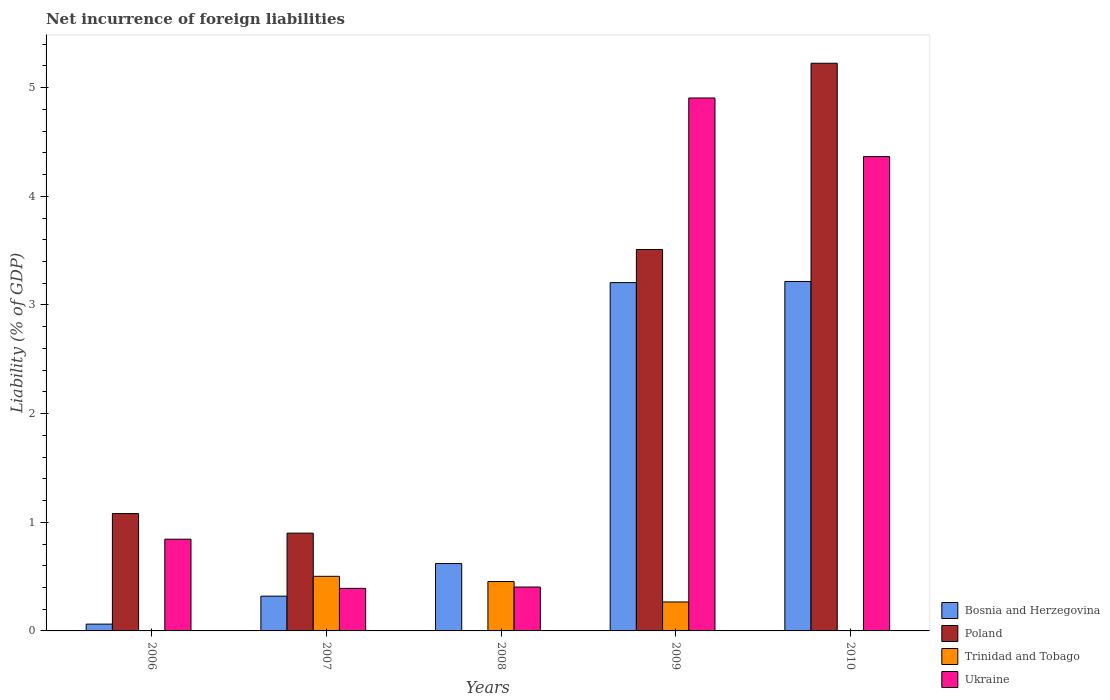How many different coloured bars are there?
Your response must be concise. 4. How many groups of bars are there?
Keep it short and to the point. 5. How many bars are there on the 1st tick from the left?
Offer a terse response. 3. What is the label of the 3rd group of bars from the left?
Provide a short and direct response. 2008. In how many cases, is the number of bars for a given year not equal to the number of legend labels?
Make the answer very short. 3. What is the net incurrence of foreign liabilities in Ukraine in 2009?
Your answer should be compact. 4.91. Across all years, what is the maximum net incurrence of foreign liabilities in Trinidad and Tobago?
Give a very brief answer. 0.5. In which year was the net incurrence of foreign liabilities in Trinidad and Tobago maximum?
Provide a succinct answer. 2007. What is the total net incurrence of foreign liabilities in Trinidad and Tobago in the graph?
Offer a terse response. 1.22. What is the difference between the net incurrence of foreign liabilities in Bosnia and Herzegovina in 2007 and that in 2009?
Your response must be concise. -2.89. What is the difference between the net incurrence of foreign liabilities in Poland in 2008 and the net incurrence of foreign liabilities in Trinidad and Tobago in 2007?
Your answer should be very brief. -0.5. What is the average net incurrence of foreign liabilities in Trinidad and Tobago per year?
Offer a terse response. 0.24. In the year 2010, what is the difference between the net incurrence of foreign liabilities in Bosnia and Herzegovina and net incurrence of foreign liabilities in Poland?
Offer a terse response. -2.01. What is the ratio of the net incurrence of foreign liabilities in Ukraine in 2007 to that in 2008?
Your answer should be very brief. 0.97. Is the difference between the net incurrence of foreign liabilities in Bosnia and Herzegovina in 2006 and 2010 greater than the difference between the net incurrence of foreign liabilities in Poland in 2006 and 2010?
Your answer should be very brief. Yes. What is the difference between the highest and the second highest net incurrence of foreign liabilities in Ukraine?
Keep it short and to the point. 0.54. What is the difference between the highest and the lowest net incurrence of foreign liabilities in Bosnia and Herzegovina?
Your answer should be compact. 3.15. In how many years, is the net incurrence of foreign liabilities in Trinidad and Tobago greater than the average net incurrence of foreign liabilities in Trinidad and Tobago taken over all years?
Provide a succinct answer. 3. Is it the case that in every year, the sum of the net incurrence of foreign liabilities in Poland and net incurrence of foreign liabilities in Ukraine is greater than the sum of net incurrence of foreign liabilities in Trinidad and Tobago and net incurrence of foreign liabilities in Bosnia and Herzegovina?
Provide a short and direct response. No. Is it the case that in every year, the sum of the net incurrence of foreign liabilities in Bosnia and Herzegovina and net incurrence of foreign liabilities in Poland is greater than the net incurrence of foreign liabilities in Ukraine?
Offer a terse response. Yes. Are all the bars in the graph horizontal?
Your answer should be very brief. No. What is the difference between two consecutive major ticks on the Y-axis?
Your answer should be compact. 1. Does the graph contain any zero values?
Provide a succinct answer. Yes. Where does the legend appear in the graph?
Your answer should be compact. Bottom right. What is the title of the graph?
Your answer should be very brief. Net incurrence of foreign liabilities. Does "Somalia" appear as one of the legend labels in the graph?
Your answer should be very brief. No. What is the label or title of the Y-axis?
Make the answer very short. Liability (% of GDP). What is the Liability (% of GDP) in Bosnia and Herzegovina in 2006?
Your answer should be very brief. 0.06. What is the Liability (% of GDP) in Poland in 2006?
Keep it short and to the point. 1.08. What is the Liability (% of GDP) of Trinidad and Tobago in 2006?
Make the answer very short. 0. What is the Liability (% of GDP) in Ukraine in 2006?
Offer a terse response. 0.84. What is the Liability (% of GDP) of Bosnia and Herzegovina in 2007?
Your answer should be very brief. 0.32. What is the Liability (% of GDP) in Poland in 2007?
Your answer should be very brief. 0.9. What is the Liability (% of GDP) in Trinidad and Tobago in 2007?
Ensure brevity in your answer.  0.5. What is the Liability (% of GDP) of Ukraine in 2007?
Ensure brevity in your answer.  0.39. What is the Liability (% of GDP) of Bosnia and Herzegovina in 2008?
Provide a succinct answer. 0.62. What is the Liability (% of GDP) of Poland in 2008?
Provide a short and direct response. 0. What is the Liability (% of GDP) of Trinidad and Tobago in 2008?
Provide a succinct answer. 0.45. What is the Liability (% of GDP) in Ukraine in 2008?
Provide a succinct answer. 0.4. What is the Liability (% of GDP) in Bosnia and Herzegovina in 2009?
Keep it short and to the point. 3.21. What is the Liability (% of GDP) of Poland in 2009?
Give a very brief answer. 3.51. What is the Liability (% of GDP) in Trinidad and Tobago in 2009?
Offer a very short reply. 0.27. What is the Liability (% of GDP) of Ukraine in 2009?
Offer a terse response. 4.91. What is the Liability (% of GDP) in Bosnia and Herzegovina in 2010?
Give a very brief answer. 3.22. What is the Liability (% of GDP) in Poland in 2010?
Ensure brevity in your answer.  5.22. What is the Liability (% of GDP) of Trinidad and Tobago in 2010?
Provide a short and direct response. 0. What is the Liability (% of GDP) in Ukraine in 2010?
Provide a succinct answer. 4.37. Across all years, what is the maximum Liability (% of GDP) of Bosnia and Herzegovina?
Offer a very short reply. 3.22. Across all years, what is the maximum Liability (% of GDP) in Poland?
Offer a terse response. 5.22. Across all years, what is the maximum Liability (% of GDP) in Trinidad and Tobago?
Ensure brevity in your answer.  0.5. Across all years, what is the maximum Liability (% of GDP) in Ukraine?
Your response must be concise. 4.91. Across all years, what is the minimum Liability (% of GDP) in Bosnia and Herzegovina?
Provide a succinct answer. 0.06. Across all years, what is the minimum Liability (% of GDP) in Poland?
Offer a terse response. 0. Across all years, what is the minimum Liability (% of GDP) in Ukraine?
Give a very brief answer. 0.39. What is the total Liability (% of GDP) in Bosnia and Herzegovina in the graph?
Your answer should be very brief. 7.42. What is the total Liability (% of GDP) of Poland in the graph?
Provide a succinct answer. 10.72. What is the total Liability (% of GDP) in Trinidad and Tobago in the graph?
Keep it short and to the point. 1.22. What is the total Liability (% of GDP) of Ukraine in the graph?
Your answer should be compact. 10.91. What is the difference between the Liability (% of GDP) in Bosnia and Herzegovina in 2006 and that in 2007?
Give a very brief answer. -0.26. What is the difference between the Liability (% of GDP) in Poland in 2006 and that in 2007?
Keep it short and to the point. 0.18. What is the difference between the Liability (% of GDP) of Ukraine in 2006 and that in 2007?
Your answer should be very brief. 0.45. What is the difference between the Liability (% of GDP) in Bosnia and Herzegovina in 2006 and that in 2008?
Offer a very short reply. -0.56. What is the difference between the Liability (% of GDP) in Ukraine in 2006 and that in 2008?
Provide a short and direct response. 0.44. What is the difference between the Liability (% of GDP) of Bosnia and Herzegovina in 2006 and that in 2009?
Keep it short and to the point. -3.14. What is the difference between the Liability (% of GDP) of Poland in 2006 and that in 2009?
Give a very brief answer. -2.43. What is the difference between the Liability (% of GDP) in Ukraine in 2006 and that in 2009?
Offer a terse response. -4.06. What is the difference between the Liability (% of GDP) of Bosnia and Herzegovina in 2006 and that in 2010?
Your answer should be compact. -3.15. What is the difference between the Liability (% of GDP) in Poland in 2006 and that in 2010?
Keep it short and to the point. -4.14. What is the difference between the Liability (% of GDP) of Ukraine in 2006 and that in 2010?
Ensure brevity in your answer.  -3.52. What is the difference between the Liability (% of GDP) of Trinidad and Tobago in 2007 and that in 2008?
Provide a short and direct response. 0.05. What is the difference between the Liability (% of GDP) of Ukraine in 2007 and that in 2008?
Ensure brevity in your answer.  -0.01. What is the difference between the Liability (% of GDP) of Bosnia and Herzegovina in 2007 and that in 2009?
Keep it short and to the point. -2.89. What is the difference between the Liability (% of GDP) of Poland in 2007 and that in 2009?
Offer a very short reply. -2.61. What is the difference between the Liability (% of GDP) in Trinidad and Tobago in 2007 and that in 2009?
Your answer should be compact. 0.24. What is the difference between the Liability (% of GDP) in Ukraine in 2007 and that in 2009?
Make the answer very short. -4.51. What is the difference between the Liability (% of GDP) in Bosnia and Herzegovina in 2007 and that in 2010?
Your answer should be compact. -2.9. What is the difference between the Liability (% of GDP) in Poland in 2007 and that in 2010?
Provide a short and direct response. -4.32. What is the difference between the Liability (% of GDP) in Ukraine in 2007 and that in 2010?
Offer a very short reply. -3.97. What is the difference between the Liability (% of GDP) of Bosnia and Herzegovina in 2008 and that in 2009?
Keep it short and to the point. -2.59. What is the difference between the Liability (% of GDP) of Trinidad and Tobago in 2008 and that in 2009?
Ensure brevity in your answer.  0.19. What is the difference between the Liability (% of GDP) of Ukraine in 2008 and that in 2009?
Give a very brief answer. -4.5. What is the difference between the Liability (% of GDP) of Bosnia and Herzegovina in 2008 and that in 2010?
Your response must be concise. -2.6. What is the difference between the Liability (% of GDP) of Ukraine in 2008 and that in 2010?
Give a very brief answer. -3.96. What is the difference between the Liability (% of GDP) in Bosnia and Herzegovina in 2009 and that in 2010?
Your answer should be very brief. -0.01. What is the difference between the Liability (% of GDP) in Poland in 2009 and that in 2010?
Your response must be concise. -1.71. What is the difference between the Liability (% of GDP) of Ukraine in 2009 and that in 2010?
Your answer should be compact. 0.54. What is the difference between the Liability (% of GDP) in Bosnia and Herzegovina in 2006 and the Liability (% of GDP) in Poland in 2007?
Offer a terse response. -0.84. What is the difference between the Liability (% of GDP) of Bosnia and Herzegovina in 2006 and the Liability (% of GDP) of Trinidad and Tobago in 2007?
Your answer should be compact. -0.44. What is the difference between the Liability (% of GDP) of Bosnia and Herzegovina in 2006 and the Liability (% of GDP) of Ukraine in 2007?
Offer a terse response. -0.33. What is the difference between the Liability (% of GDP) in Poland in 2006 and the Liability (% of GDP) in Trinidad and Tobago in 2007?
Make the answer very short. 0.58. What is the difference between the Liability (% of GDP) in Poland in 2006 and the Liability (% of GDP) in Ukraine in 2007?
Offer a very short reply. 0.69. What is the difference between the Liability (% of GDP) of Bosnia and Herzegovina in 2006 and the Liability (% of GDP) of Trinidad and Tobago in 2008?
Provide a succinct answer. -0.39. What is the difference between the Liability (% of GDP) of Bosnia and Herzegovina in 2006 and the Liability (% of GDP) of Ukraine in 2008?
Offer a very short reply. -0.34. What is the difference between the Liability (% of GDP) in Poland in 2006 and the Liability (% of GDP) in Trinidad and Tobago in 2008?
Ensure brevity in your answer.  0.63. What is the difference between the Liability (% of GDP) in Poland in 2006 and the Liability (% of GDP) in Ukraine in 2008?
Give a very brief answer. 0.68. What is the difference between the Liability (% of GDP) in Bosnia and Herzegovina in 2006 and the Liability (% of GDP) in Poland in 2009?
Provide a short and direct response. -3.45. What is the difference between the Liability (% of GDP) of Bosnia and Herzegovina in 2006 and the Liability (% of GDP) of Trinidad and Tobago in 2009?
Provide a short and direct response. -0.2. What is the difference between the Liability (% of GDP) of Bosnia and Herzegovina in 2006 and the Liability (% of GDP) of Ukraine in 2009?
Keep it short and to the point. -4.84. What is the difference between the Liability (% of GDP) in Poland in 2006 and the Liability (% of GDP) in Trinidad and Tobago in 2009?
Make the answer very short. 0.81. What is the difference between the Liability (% of GDP) in Poland in 2006 and the Liability (% of GDP) in Ukraine in 2009?
Ensure brevity in your answer.  -3.83. What is the difference between the Liability (% of GDP) of Bosnia and Herzegovina in 2006 and the Liability (% of GDP) of Poland in 2010?
Give a very brief answer. -5.16. What is the difference between the Liability (% of GDP) in Bosnia and Herzegovina in 2006 and the Liability (% of GDP) in Ukraine in 2010?
Keep it short and to the point. -4.3. What is the difference between the Liability (% of GDP) of Poland in 2006 and the Liability (% of GDP) of Ukraine in 2010?
Ensure brevity in your answer.  -3.29. What is the difference between the Liability (% of GDP) in Bosnia and Herzegovina in 2007 and the Liability (% of GDP) in Trinidad and Tobago in 2008?
Keep it short and to the point. -0.13. What is the difference between the Liability (% of GDP) in Bosnia and Herzegovina in 2007 and the Liability (% of GDP) in Ukraine in 2008?
Keep it short and to the point. -0.08. What is the difference between the Liability (% of GDP) of Poland in 2007 and the Liability (% of GDP) of Trinidad and Tobago in 2008?
Make the answer very short. 0.45. What is the difference between the Liability (% of GDP) of Poland in 2007 and the Liability (% of GDP) of Ukraine in 2008?
Give a very brief answer. 0.5. What is the difference between the Liability (% of GDP) in Trinidad and Tobago in 2007 and the Liability (% of GDP) in Ukraine in 2008?
Your answer should be very brief. 0.1. What is the difference between the Liability (% of GDP) in Bosnia and Herzegovina in 2007 and the Liability (% of GDP) in Poland in 2009?
Provide a succinct answer. -3.19. What is the difference between the Liability (% of GDP) of Bosnia and Herzegovina in 2007 and the Liability (% of GDP) of Trinidad and Tobago in 2009?
Your response must be concise. 0.05. What is the difference between the Liability (% of GDP) of Bosnia and Herzegovina in 2007 and the Liability (% of GDP) of Ukraine in 2009?
Ensure brevity in your answer.  -4.58. What is the difference between the Liability (% of GDP) in Poland in 2007 and the Liability (% of GDP) in Trinidad and Tobago in 2009?
Offer a terse response. 0.63. What is the difference between the Liability (% of GDP) of Poland in 2007 and the Liability (% of GDP) of Ukraine in 2009?
Give a very brief answer. -4. What is the difference between the Liability (% of GDP) of Trinidad and Tobago in 2007 and the Liability (% of GDP) of Ukraine in 2009?
Provide a succinct answer. -4.4. What is the difference between the Liability (% of GDP) in Bosnia and Herzegovina in 2007 and the Liability (% of GDP) in Poland in 2010?
Offer a terse response. -4.9. What is the difference between the Liability (% of GDP) in Bosnia and Herzegovina in 2007 and the Liability (% of GDP) in Ukraine in 2010?
Provide a short and direct response. -4.05. What is the difference between the Liability (% of GDP) in Poland in 2007 and the Liability (% of GDP) in Ukraine in 2010?
Your answer should be very brief. -3.47. What is the difference between the Liability (% of GDP) in Trinidad and Tobago in 2007 and the Liability (% of GDP) in Ukraine in 2010?
Give a very brief answer. -3.86. What is the difference between the Liability (% of GDP) of Bosnia and Herzegovina in 2008 and the Liability (% of GDP) of Poland in 2009?
Keep it short and to the point. -2.89. What is the difference between the Liability (% of GDP) in Bosnia and Herzegovina in 2008 and the Liability (% of GDP) in Trinidad and Tobago in 2009?
Keep it short and to the point. 0.35. What is the difference between the Liability (% of GDP) of Bosnia and Herzegovina in 2008 and the Liability (% of GDP) of Ukraine in 2009?
Provide a succinct answer. -4.29. What is the difference between the Liability (% of GDP) in Trinidad and Tobago in 2008 and the Liability (% of GDP) in Ukraine in 2009?
Make the answer very short. -4.45. What is the difference between the Liability (% of GDP) of Bosnia and Herzegovina in 2008 and the Liability (% of GDP) of Poland in 2010?
Make the answer very short. -4.6. What is the difference between the Liability (% of GDP) of Bosnia and Herzegovina in 2008 and the Liability (% of GDP) of Ukraine in 2010?
Your response must be concise. -3.75. What is the difference between the Liability (% of GDP) in Trinidad and Tobago in 2008 and the Liability (% of GDP) in Ukraine in 2010?
Provide a succinct answer. -3.91. What is the difference between the Liability (% of GDP) in Bosnia and Herzegovina in 2009 and the Liability (% of GDP) in Poland in 2010?
Offer a terse response. -2.02. What is the difference between the Liability (% of GDP) in Bosnia and Herzegovina in 2009 and the Liability (% of GDP) in Ukraine in 2010?
Ensure brevity in your answer.  -1.16. What is the difference between the Liability (% of GDP) of Poland in 2009 and the Liability (% of GDP) of Ukraine in 2010?
Offer a terse response. -0.85. What is the difference between the Liability (% of GDP) in Trinidad and Tobago in 2009 and the Liability (% of GDP) in Ukraine in 2010?
Offer a terse response. -4.1. What is the average Liability (% of GDP) of Bosnia and Herzegovina per year?
Your answer should be compact. 1.48. What is the average Liability (% of GDP) in Poland per year?
Your response must be concise. 2.14. What is the average Liability (% of GDP) of Trinidad and Tobago per year?
Make the answer very short. 0.24. What is the average Liability (% of GDP) of Ukraine per year?
Provide a short and direct response. 2.18. In the year 2006, what is the difference between the Liability (% of GDP) of Bosnia and Herzegovina and Liability (% of GDP) of Poland?
Give a very brief answer. -1.02. In the year 2006, what is the difference between the Liability (% of GDP) in Bosnia and Herzegovina and Liability (% of GDP) in Ukraine?
Give a very brief answer. -0.78. In the year 2006, what is the difference between the Liability (% of GDP) in Poland and Liability (% of GDP) in Ukraine?
Give a very brief answer. 0.24. In the year 2007, what is the difference between the Liability (% of GDP) of Bosnia and Herzegovina and Liability (% of GDP) of Poland?
Your answer should be compact. -0.58. In the year 2007, what is the difference between the Liability (% of GDP) of Bosnia and Herzegovina and Liability (% of GDP) of Trinidad and Tobago?
Provide a succinct answer. -0.18. In the year 2007, what is the difference between the Liability (% of GDP) in Bosnia and Herzegovina and Liability (% of GDP) in Ukraine?
Make the answer very short. -0.07. In the year 2007, what is the difference between the Liability (% of GDP) in Poland and Liability (% of GDP) in Trinidad and Tobago?
Offer a very short reply. 0.4. In the year 2007, what is the difference between the Liability (% of GDP) of Poland and Liability (% of GDP) of Ukraine?
Make the answer very short. 0.51. In the year 2007, what is the difference between the Liability (% of GDP) of Trinidad and Tobago and Liability (% of GDP) of Ukraine?
Offer a very short reply. 0.11. In the year 2008, what is the difference between the Liability (% of GDP) in Bosnia and Herzegovina and Liability (% of GDP) in Trinidad and Tobago?
Your answer should be compact. 0.17. In the year 2008, what is the difference between the Liability (% of GDP) of Bosnia and Herzegovina and Liability (% of GDP) of Ukraine?
Give a very brief answer. 0.22. In the year 2008, what is the difference between the Liability (% of GDP) of Trinidad and Tobago and Liability (% of GDP) of Ukraine?
Your answer should be compact. 0.05. In the year 2009, what is the difference between the Liability (% of GDP) in Bosnia and Herzegovina and Liability (% of GDP) in Poland?
Make the answer very short. -0.3. In the year 2009, what is the difference between the Liability (% of GDP) of Bosnia and Herzegovina and Liability (% of GDP) of Trinidad and Tobago?
Ensure brevity in your answer.  2.94. In the year 2009, what is the difference between the Liability (% of GDP) in Bosnia and Herzegovina and Liability (% of GDP) in Ukraine?
Offer a terse response. -1.7. In the year 2009, what is the difference between the Liability (% of GDP) in Poland and Liability (% of GDP) in Trinidad and Tobago?
Make the answer very short. 3.24. In the year 2009, what is the difference between the Liability (% of GDP) of Poland and Liability (% of GDP) of Ukraine?
Make the answer very short. -1.39. In the year 2009, what is the difference between the Liability (% of GDP) of Trinidad and Tobago and Liability (% of GDP) of Ukraine?
Give a very brief answer. -4.64. In the year 2010, what is the difference between the Liability (% of GDP) of Bosnia and Herzegovina and Liability (% of GDP) of Poland?
Give a very brief answer. -2.01. In the year 2010, what is the difference between the Liability (% of GDP) in Bosnia and Herzegovina and Liability (% of GDP) in Ukraine?
Offer a terse response. -1.15. In the year 2010, what is the difference between the Liability (% of GDP) of Poland and Liability (% of GDP) of Ukraine?
Offer a terse response. 0.86. What is the ratio of the Liability (% of GDP) of Bosnia and Herzegovina in 2006 to that in 2007?
Make the answer very short. 0.2. What is the ratio of the Liability (% of GDP) of Poland in 2006 to that in 2007?
Offer a very short reply. 1.2. What is the ratio of the Liability (% of GDP) of Ukraine in 2006 to that in 2007?
Offer a terse response. 2.16. What is the ratio of the Liability (% of GDP) of Bosnia and Herzegovina in 2006 to that in 2008?
Provide a short and direct response. 0.1. What is the ratio of the Liability (% of GDP) of Ukraine in 2006 to that in 2008?
Give a very brief answer. 2.09. What is the ratio of the Liability (% of GDP) of Bosnia and Herzegovina in 2006 to that in 2009?
Your response must be concise. 0.02. What is the ratio of the Liability (% of GDP) in Poland in 2006 to that in 2009?
Your answer should be compact. 0.31. What is the ratio of the Liability (% of GDP) of Ukraine in 2006 to that in 2009?
Provide a succinct answer. 0.17. What is the ratio of the Liability (% of GDP) of Bosnia and Herzegovina in 2006 to that in 2010?
Ensure brevity in your answer.  0.02. What is the ratio of the Liability (% of GDP) of Poland in 2006 to that in 2010?
Give a very brief answer. 0.21. What is the ratio of the Liability (% of GDP) of Ukraine in 2006 to that in 2010?
Your answer should be very brief. 0.19. What is the ratio of the Liability (% of GDP) of Bosnia and Herzegovina in 2007 to that in 2008?
Provide a succinct answer. 0.52. What is the ratio of the Liability (% of GDP) of Trinidad and Tobago in 2007 to that in 2008?
Your response must be concise. 1.11. What is the ratio of the Liability (% of GDP) of Ukraine in 2007 to that in 2008?
Ensure brevity in your answer.  0.97. What is the ratio of the Liability (% of GDP) of Bosnia and Herzegovina in 2007 to that in 2009?
Your answer should be very brief. 0.1. What is the ratio of the Liability (% of GDP) in Poland in 2007 to that in 2009?
Your answer should be very brief. 0.26. What is the ratio of the Liability (% of GDP) in Trinidad and Tobago in 2007 to that in 2009?
Give a very brief answer. 1.89. What is the ratio of the Liability (% of GDP) of Ukraine in 2007 to that in 2009?
Offer a very short reply. 0.08. What is the ratio of the Liability (% of GDP) of Bosnia and Herzegovina in 2007 to that in 2010?
Ensure brevity in your answer.  0.1. What is the ratio of the Liability (% of GDP) in Poland in 2007 to that in 2010?
Your response must be concise. 0.17. What is the ratio of the Liability (% of GDP) of Ukraine in 2007 to that in 2010?
Provide a short and direct response. 0.09. What is the ratio of the Liability (% of GDP) in Bosnia and Herzegovina in 2008 to that in 2009?
Your answer should be compact. 0.19. What is the ratio of the Liability (% of GDP) in Trinidad and Tobago in 2008 to that in 2009?
Offer a very short reply. 1.71. What is the ratio of the Liability (% of GDP) in Ukraine in 2008 to that in 2009?
Provide a succinct answer. 0.08. What is the ratio of the Liability (% of GDP) of Bosnia and Herzegovina in 2008 to that in 2010?
Provide a short and direct response. 0.19. What is the ratio of the Liability (% of GDP) in Ukraine in 2008 to that in 2010?
Offer a terse response. 0.09. What is the ratio of the Liability (% of GDP) in Poland in 2009 to that in 2010?
Your answer should be very brief. 0.67. What is the ratio of the Liability (% of GDP) in Ukraine in 2009 to that in 2010?
Offer a terse response. 1.12. What is the difference between the highest and the second highest Liability (% of GDP) of Bosnia and Herzegovina?
Provide a short and direct response. 0.01. What is the difference between the highest and the second highest Liability (% of GDP) in Poland?
Make the answer very short. 1.71. What is the difference between the highest and the second highest Liability (% of GDP) of Trinidad and Tobago?
Ensure brevity in your answer.  0.05. What is the difference between the highest and the second highest Liability (% of GDP) of Ukraine?
Your answer should be very brief. 0.54. What is the difference between the highest and the lowest Liability (% of GDP) in Bosnia and Herzegovina?
Keep it short and to the point. 3.15. What is the difference between the highest and the lowest Liability (% of GDP) of Poland?
Provide a succinct answer. 5.22. What is the difference between the highest and the lowest Liability (% of GDP) of Trinidad and Tobago?
Provide a short and direct response. 0.5. What is the difference between the highest and the lowest Liability (% of GDP) in Ukraine?
Keep it short and to the point. 4.51. 